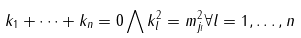Convert formula to latex. <formula><loc_0><loc_0><loc_500><loc_500>k _ { 1 } + \dots + k _ { n } = 0 \bigwedge k _ { l } ^ { 2 } = m _ { j _ { l } } ^ { 2 } \forall l = 1 , \dots , n</formula> 